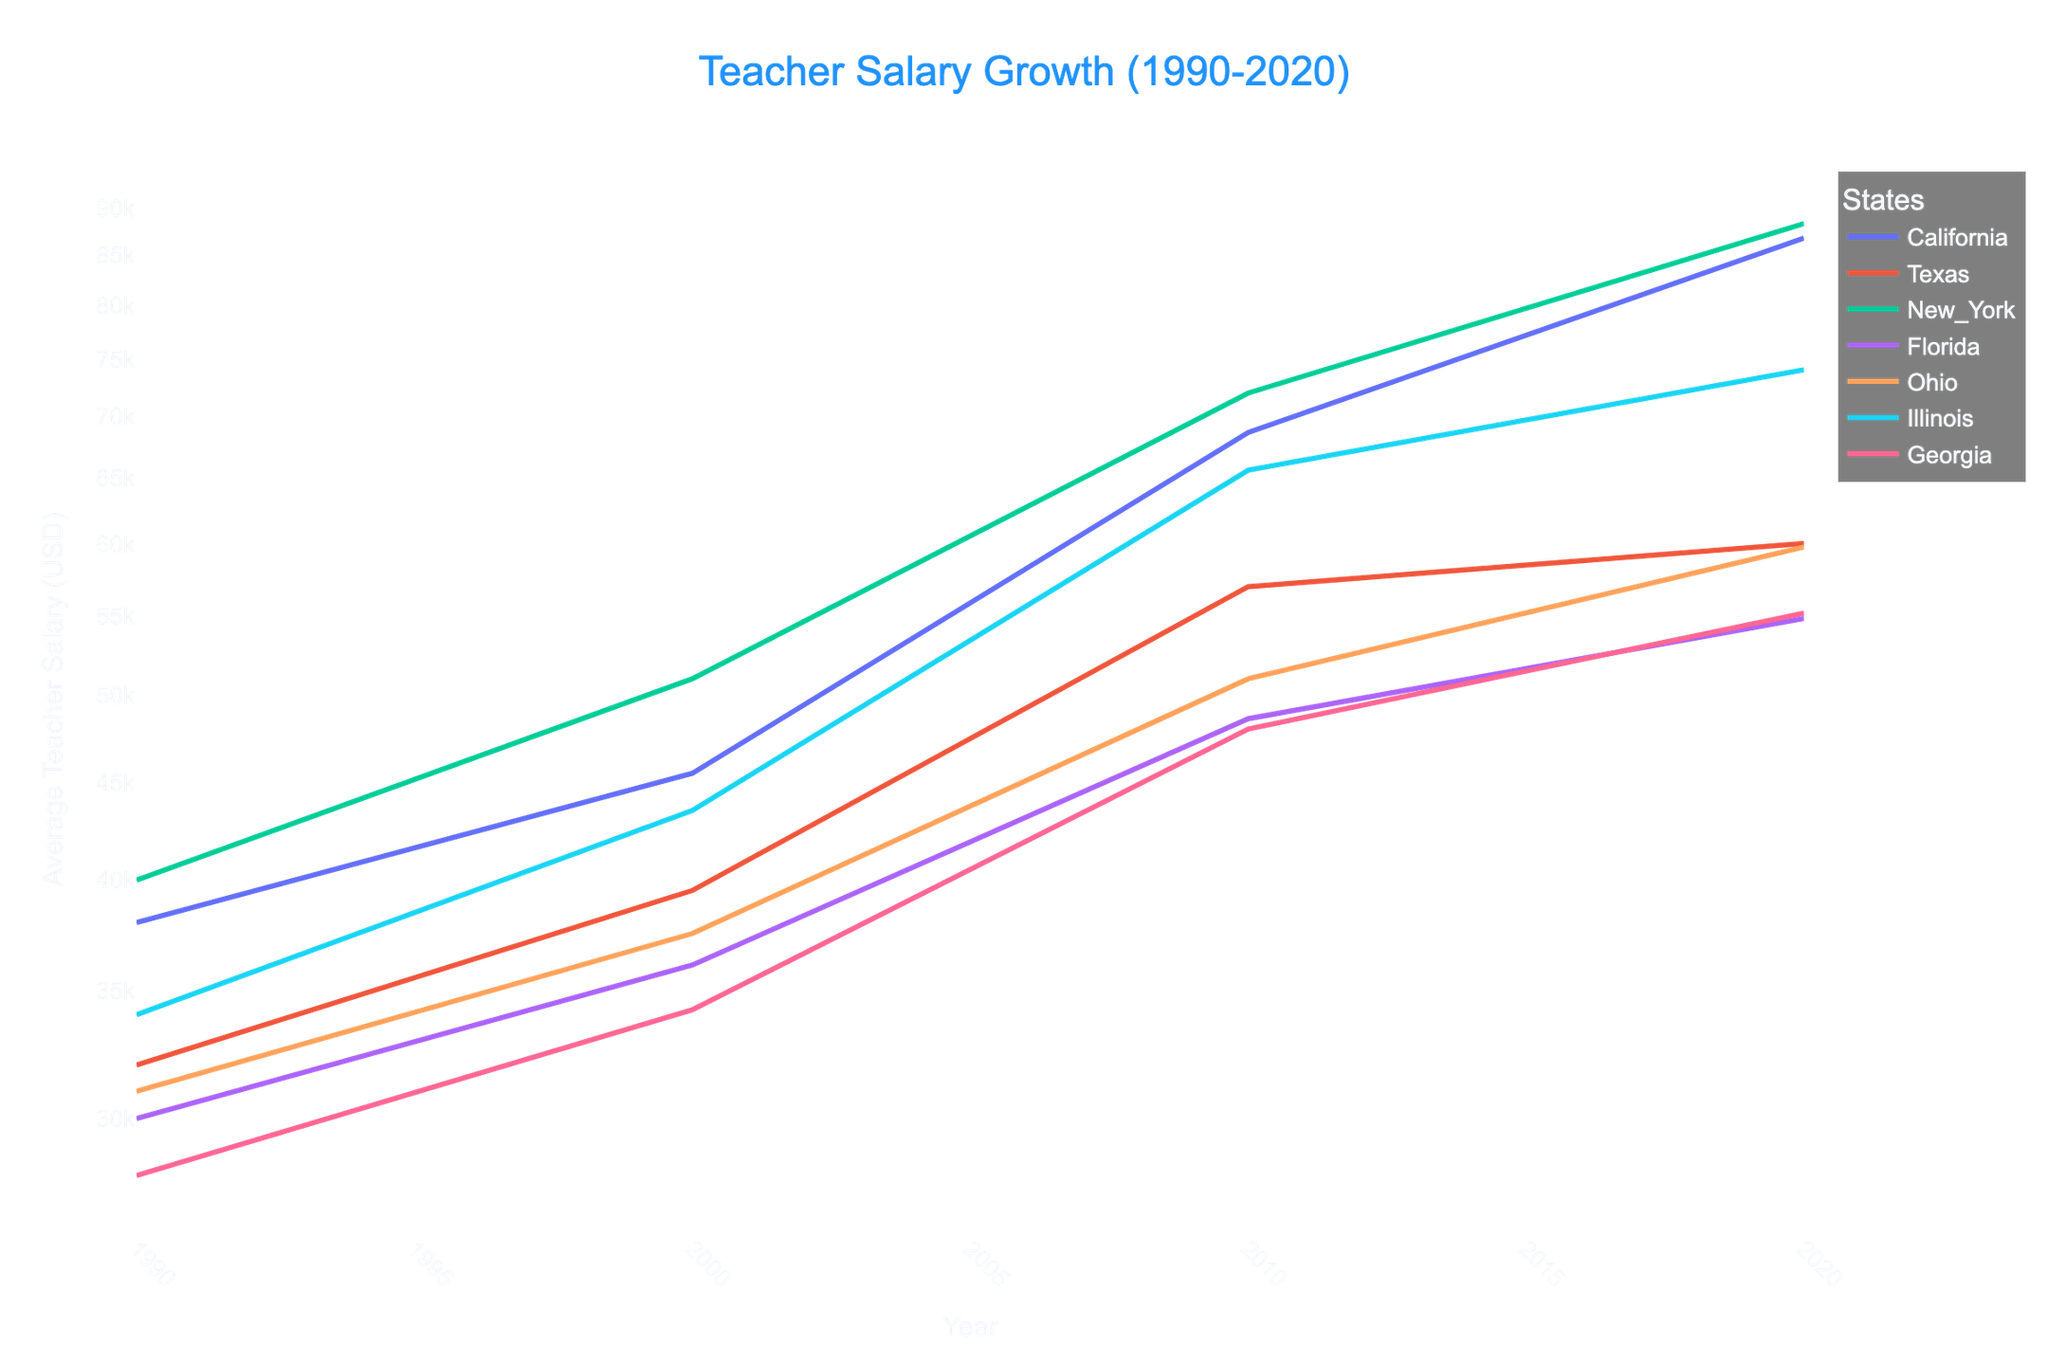What is the title of the plot? The title of the plot is located at the top center and in larger font size, making it easily identifiable.
Answer: Teacher Salary Growth (1990-2020) Which state had the highest average teacher salary in 2020? By tracing the lines up to the year 2020 on the x-axis and observing the corresponding values on the y-axis, you'll see that New York's line is the highest.
Answer: New York What is the lowest average teacher salary recorded in 1990, and which state does it belong to? Locate the 1990 data points on the x-axis and note the corresponding y-axis values. The lowest point corresponds to Georgia.
Answer: 28,000, Georgia How much did the average teacher salary in Texas grow from 1990 to 2020? Identify the Texas data points for 1990 (32,000) and 2020 (60,050), then calculate the difference: 60,050 - 32,000 = 28,050.
Answer: 28,050 Which states experienced a salary jump between 2000 and 2010? Compare the lines between 2000 and 2010 for each state and observe any steep upward slopes. California, New York, and Illinois show significant increases.
Answer: California, New York, Illinois What is the overall trend in teacher salaries from 1990 to 2020? Observe the general direction of all the lines. All lines appear to be moving upward, indicating an overall increase.
Answer: Increasing By how much did the average teacher salary in California increase between 2000 and 2010? Identify California’s salaries in 2000 (45,500) and 2010 (68,650), then calculate the difference: 68,650 - 45,500 = 23,150.
Answer: 23,150 What can be inferred from the use of a logarithmic scale in this plot? The logarithmic scale on the y-axis helps to visualize proportional growth rates and makes it easier to compare rates of increase among states, even when absolute values differ greatly.
Answer: Visualize proportional growth rates Which two states have the closest average teacher salaries in 2020? Look at the data points for 2020 and find the two states with lines that are closest together. Texas and Ohio have similar values around 60,050 and 59,800, respectively.
Answer: Texas, Ohio Across the entire period from 1990 to 2020, which state shows the least growth in average teacher salary? By visually comparing the slopes of the lines for all the states, Florida shows the least dramatic upward slope, indicating the smallest growth.
Answer: Florida 